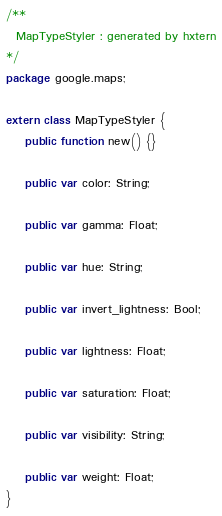Convert code to text. <code><loc_0><loc_0><loc_500><loc_500><_Haxe_>/**
  MapTypeStyler : generated by hxtern
*/
package google.maps;

extern class MapTypeStyler {
	public function new() {}

	public var color: String;

	public var gamma: Float;

	public var hue: String;

	public var invert_lightness: Bool;

	public var lightness: Float;

	public var saturation: Float;

	public var visibility: String;

	public var weight: Float;
}
</code> 